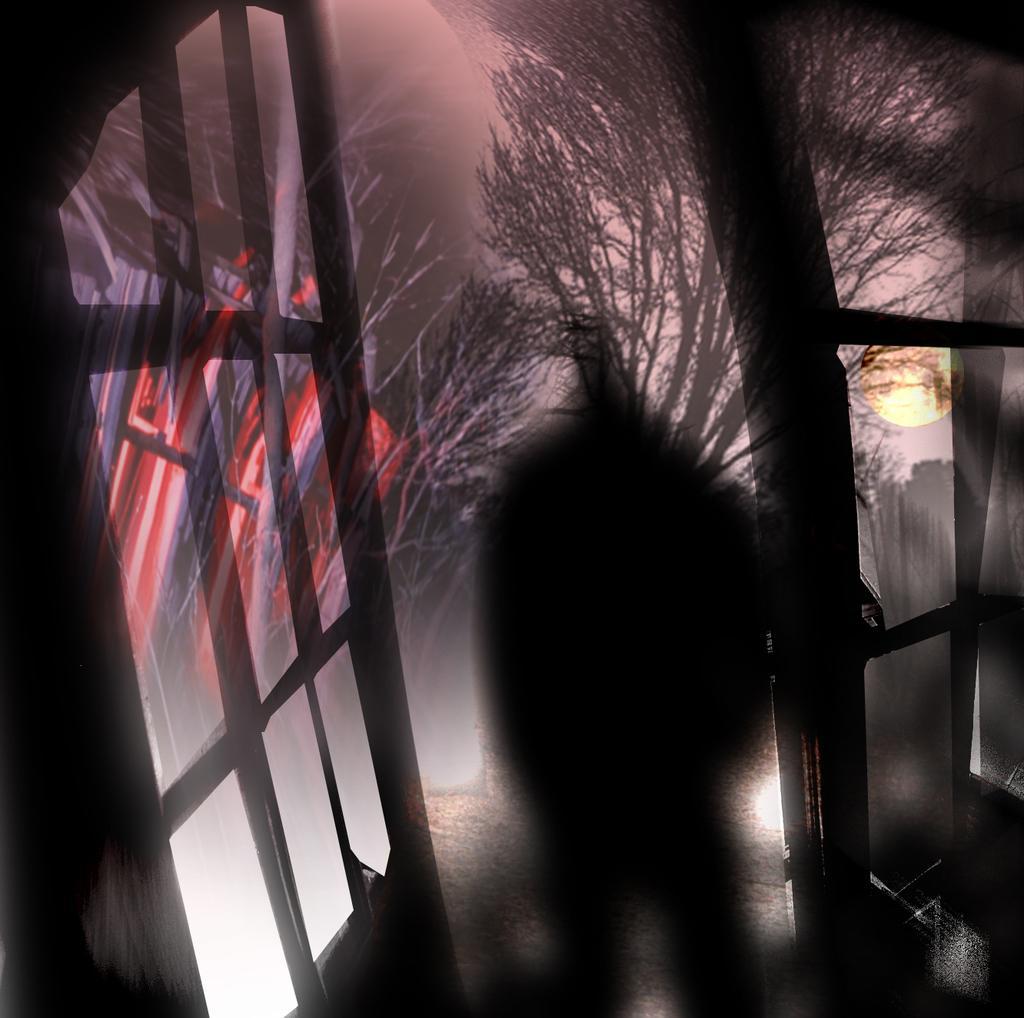Please provide a concise description of this image. This image is a painting. In this image we can see doors, sun, shadow and trees. 